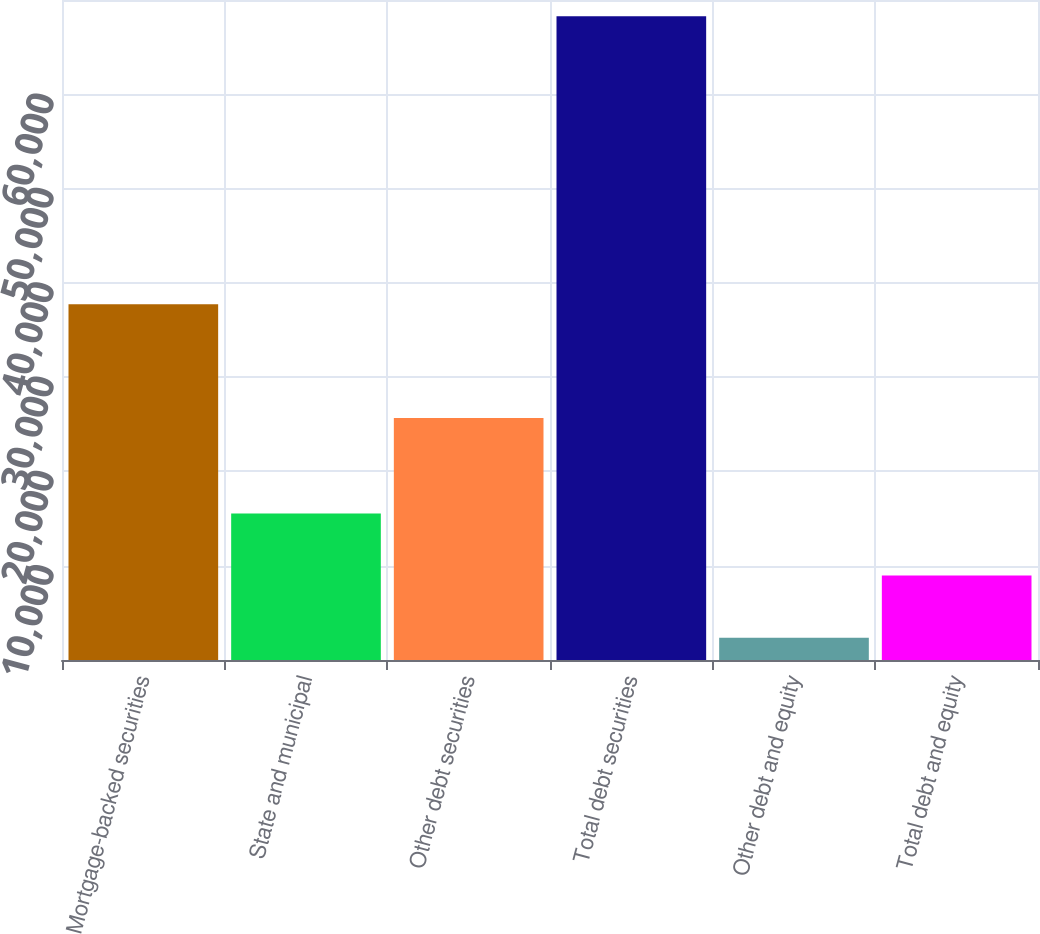Convert chart. <chart><loc_0><loc_0><loc_500><loc_500><bar_chart><fcel>Mortgage-backed securities<fcel>State and municipal<fcel>Other debt securities<fcel>Total debt securities<fcel>Other debt and equity<fcel>Total debt and equity<nl><fcel>37719<fcel>15550.8<fcel>25665<fcel>68282<fcel>2368<fcel>8959.4<nl></chart> 